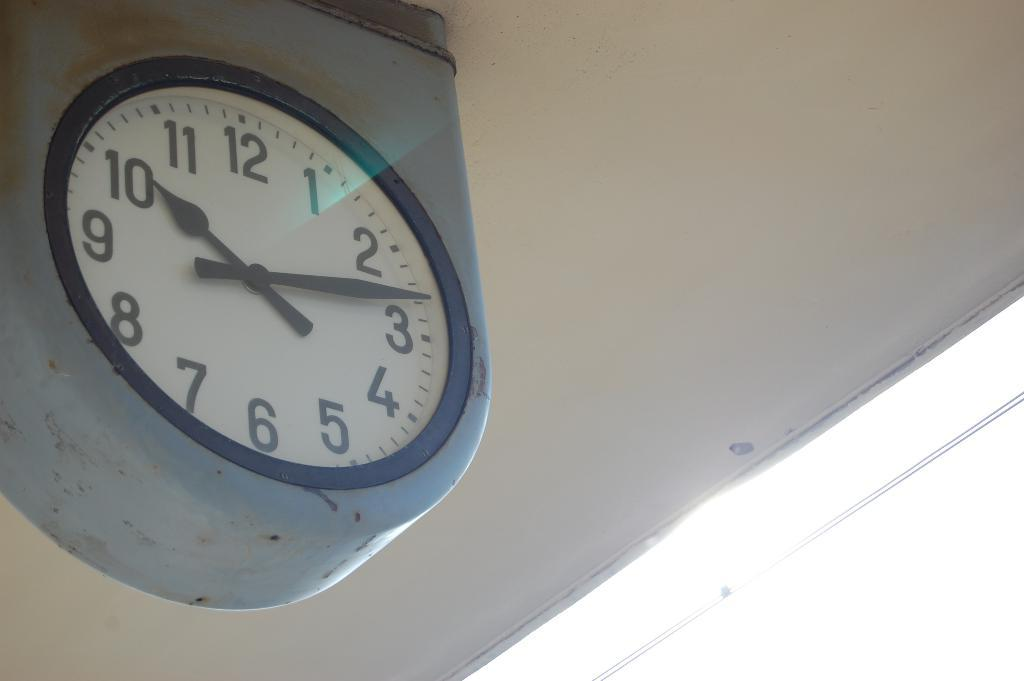<image>
Write a terse but informative summary of the picture. An analog clock shows the time to be 10:13. 